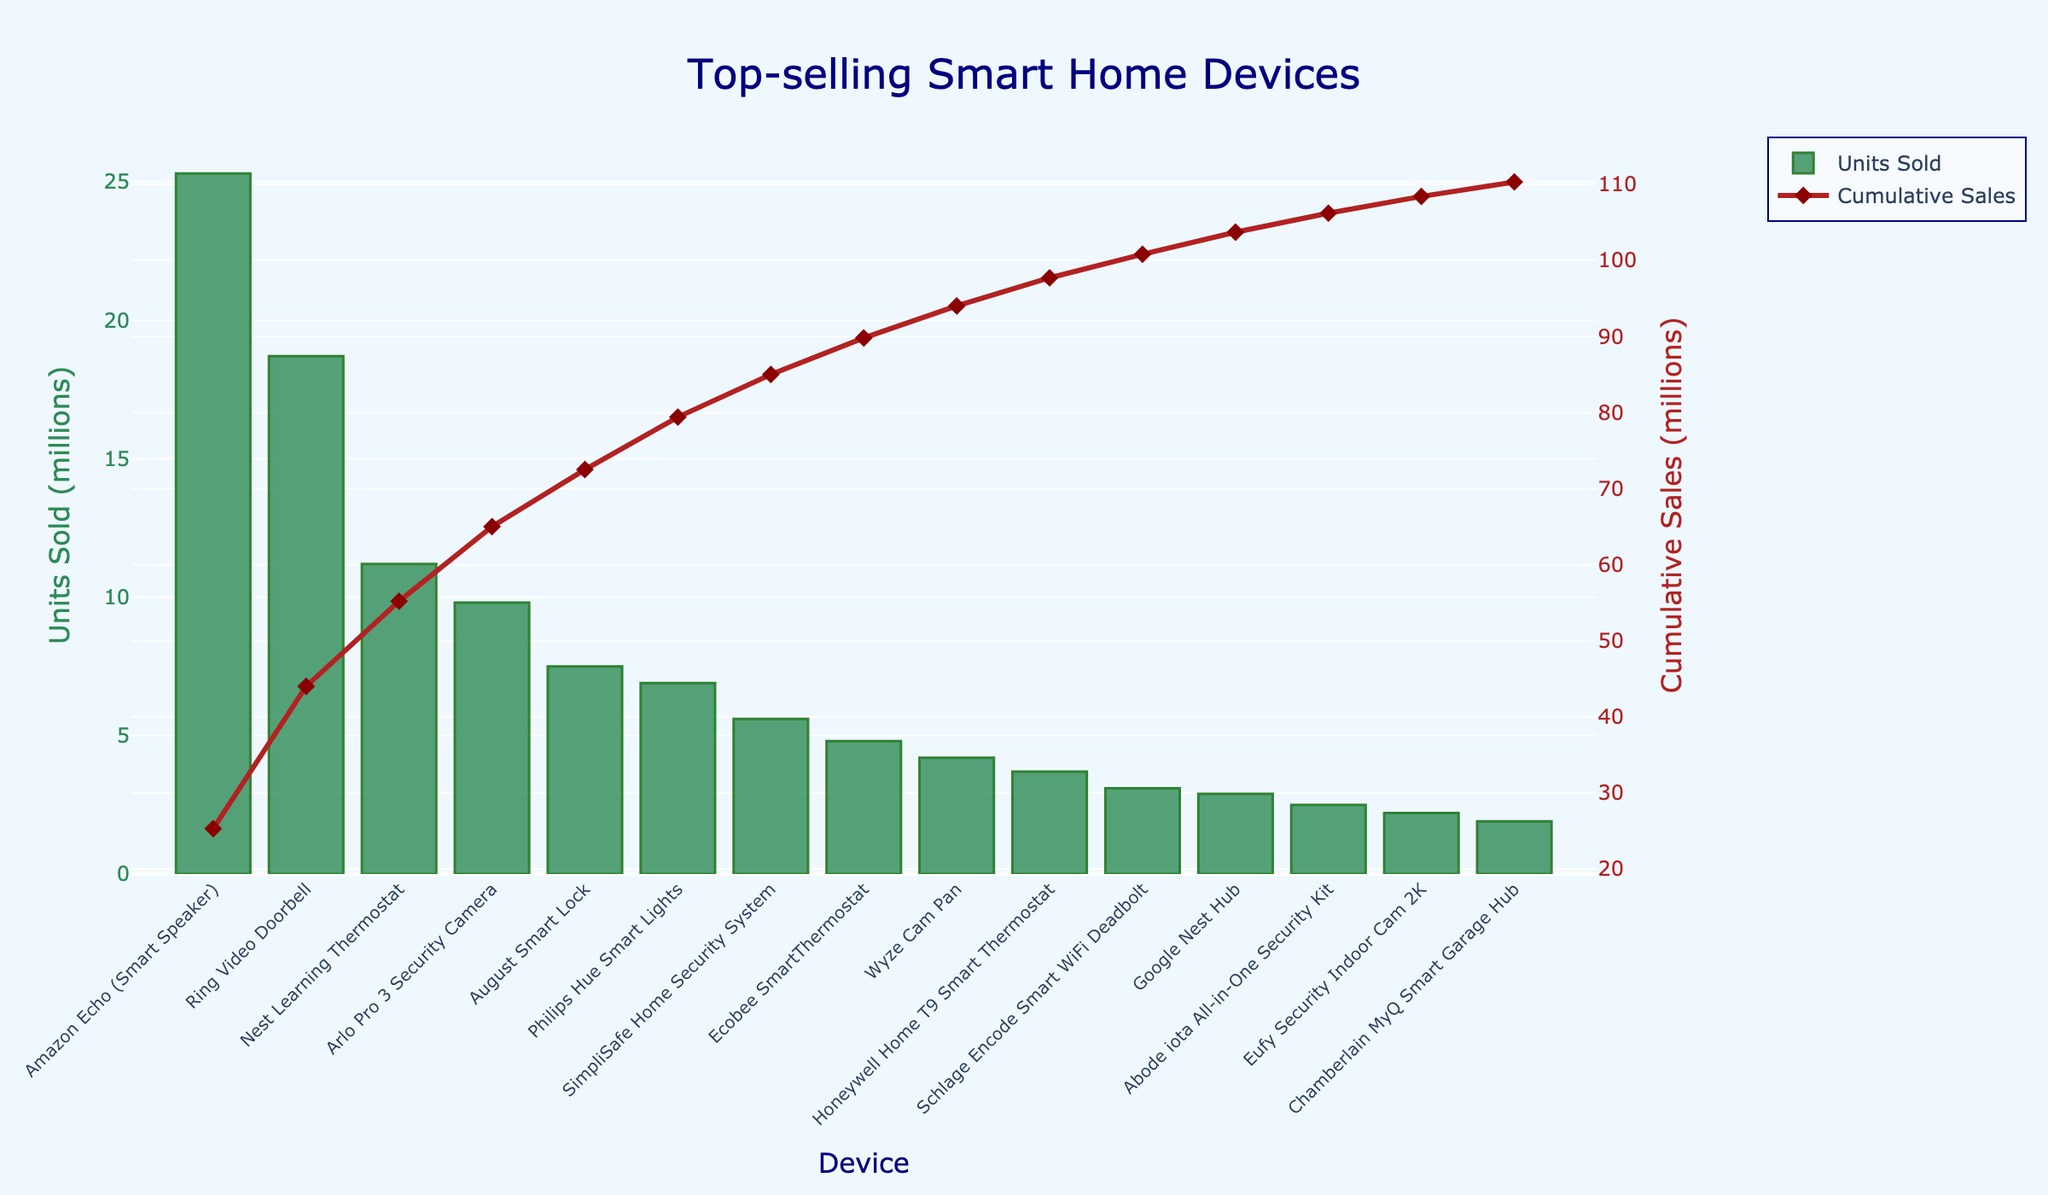Which device sold the most units? The device that sold the most units is the one with the highest bar in the bar chart. In this case, the "Amazon Echo (Smart Speaker)" has the highest bar.
Answer: Amazon Echo (Smart Speaker) What is the combined sales of smart locks? To find the combined sales of smart locks, add the units sold of the "August Smart Lock" and the "Schlage Encode Smart WiFi Deadbolt". These values are 7.5 and 3.1 million units respectively. So, 7.5 + 3.1 = 10.6 million units.
Answer: 10.6 million units How do the sales of the Nest Learning Thermostat compare to the Ecobee SmartThermostat? To compare the sales, subtract the units sold of the Ecobee SmartThermostat from the Nest Learning Thermostat. The Nest Learning Thermostat sold 11.2 million units while the Ecobee SmartThermostat sold 4.8 million units. The difference is 11.2 - 4.8 = 6.4 million units.
Answer: 6.4 million units Which device has the least cumulative sales approached by units sold? The device with the least cumulative sales can be found by looking at the end of the cumulative sales line (red) on the right y-axis. This would be the "Chamberlain MyQ Smart Garage Hub" with 1.9 million units sold.
Answer: Chamberlain MyQ Smart Garage Hub How is the cumulative sales line visually represented in the chart? The cumulative sales line is represented by a red line with diamond markers running across the chart. This line's height increases as it moves from left to right and tracks the cumulative total of units sold for the devices listed.
Answer: Red line with diamond markers What is the difference in units sold between the top-selling and bottom-selling devices? The difference between the top-selling device "Amazon Echo (Smart Speaker)" with 25.3 million units and the bottom-selling device "Chamberlain MyQ Smart Garage Hub" with 1.9 million units can be calculated as 25.3 - 1.9 = 23.4 million units.
Answer: 23.4 million units What is the cumulative sales after the top three devices? The top three devices are "Amazon Echo (Smart Speaker)", "Ring Video Doorbell", and "Nest Learning Thermostat". The cumulative sales after these three are the sum of their sales: 25.3 + 18.7 + 11.2 = 55.2 million units.
Answer: 55.2 million units Are the sales of the Philips Hue Smart Lights higher than the Wyze Cam Pan? To determine this, compare the units sold of both devices. Philips Hue Smart Lights sold 6.9 million units while Wyze Cam Pan sold 4.2 million units. Since 6.9 is greater than 4.2, Philips Hue Smart Lights sales are higher.
Answer: Yes What is the average units sold for the devices listed? To calculate the average units sold, sum the units sold for all devices and then divide by the number of devices. The total sum of units is 109.4 million units (25.3 + 18.7 + 11.2 + 9.8 + 7.5 + 6.9 + 5.6 + 4.8 + 4.2 + 3.7 + 3.1 + 2.9 + 2.5 + 2.2 + 1.9) and there are 15 devices. The average is 109.4 / 15 ≈ 7.3 million units.
Answer: 7.3 million units 